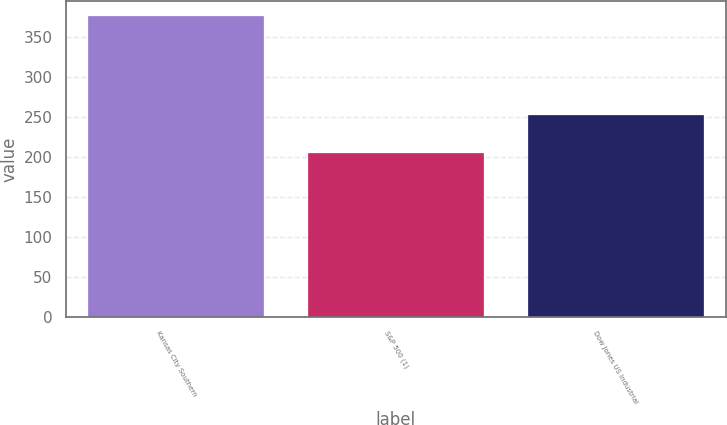Convert chart to OTSL. <chart><loc_0><loc_0><loc_500><loc_500><bar_chart><fcel>Kansas City Southern<fcel>S&P 500 (1)<fcel>Dow Jones US Industrial<nl><fcel>377.15<fcel>205.14<fcel>252.73<nl></chart> 